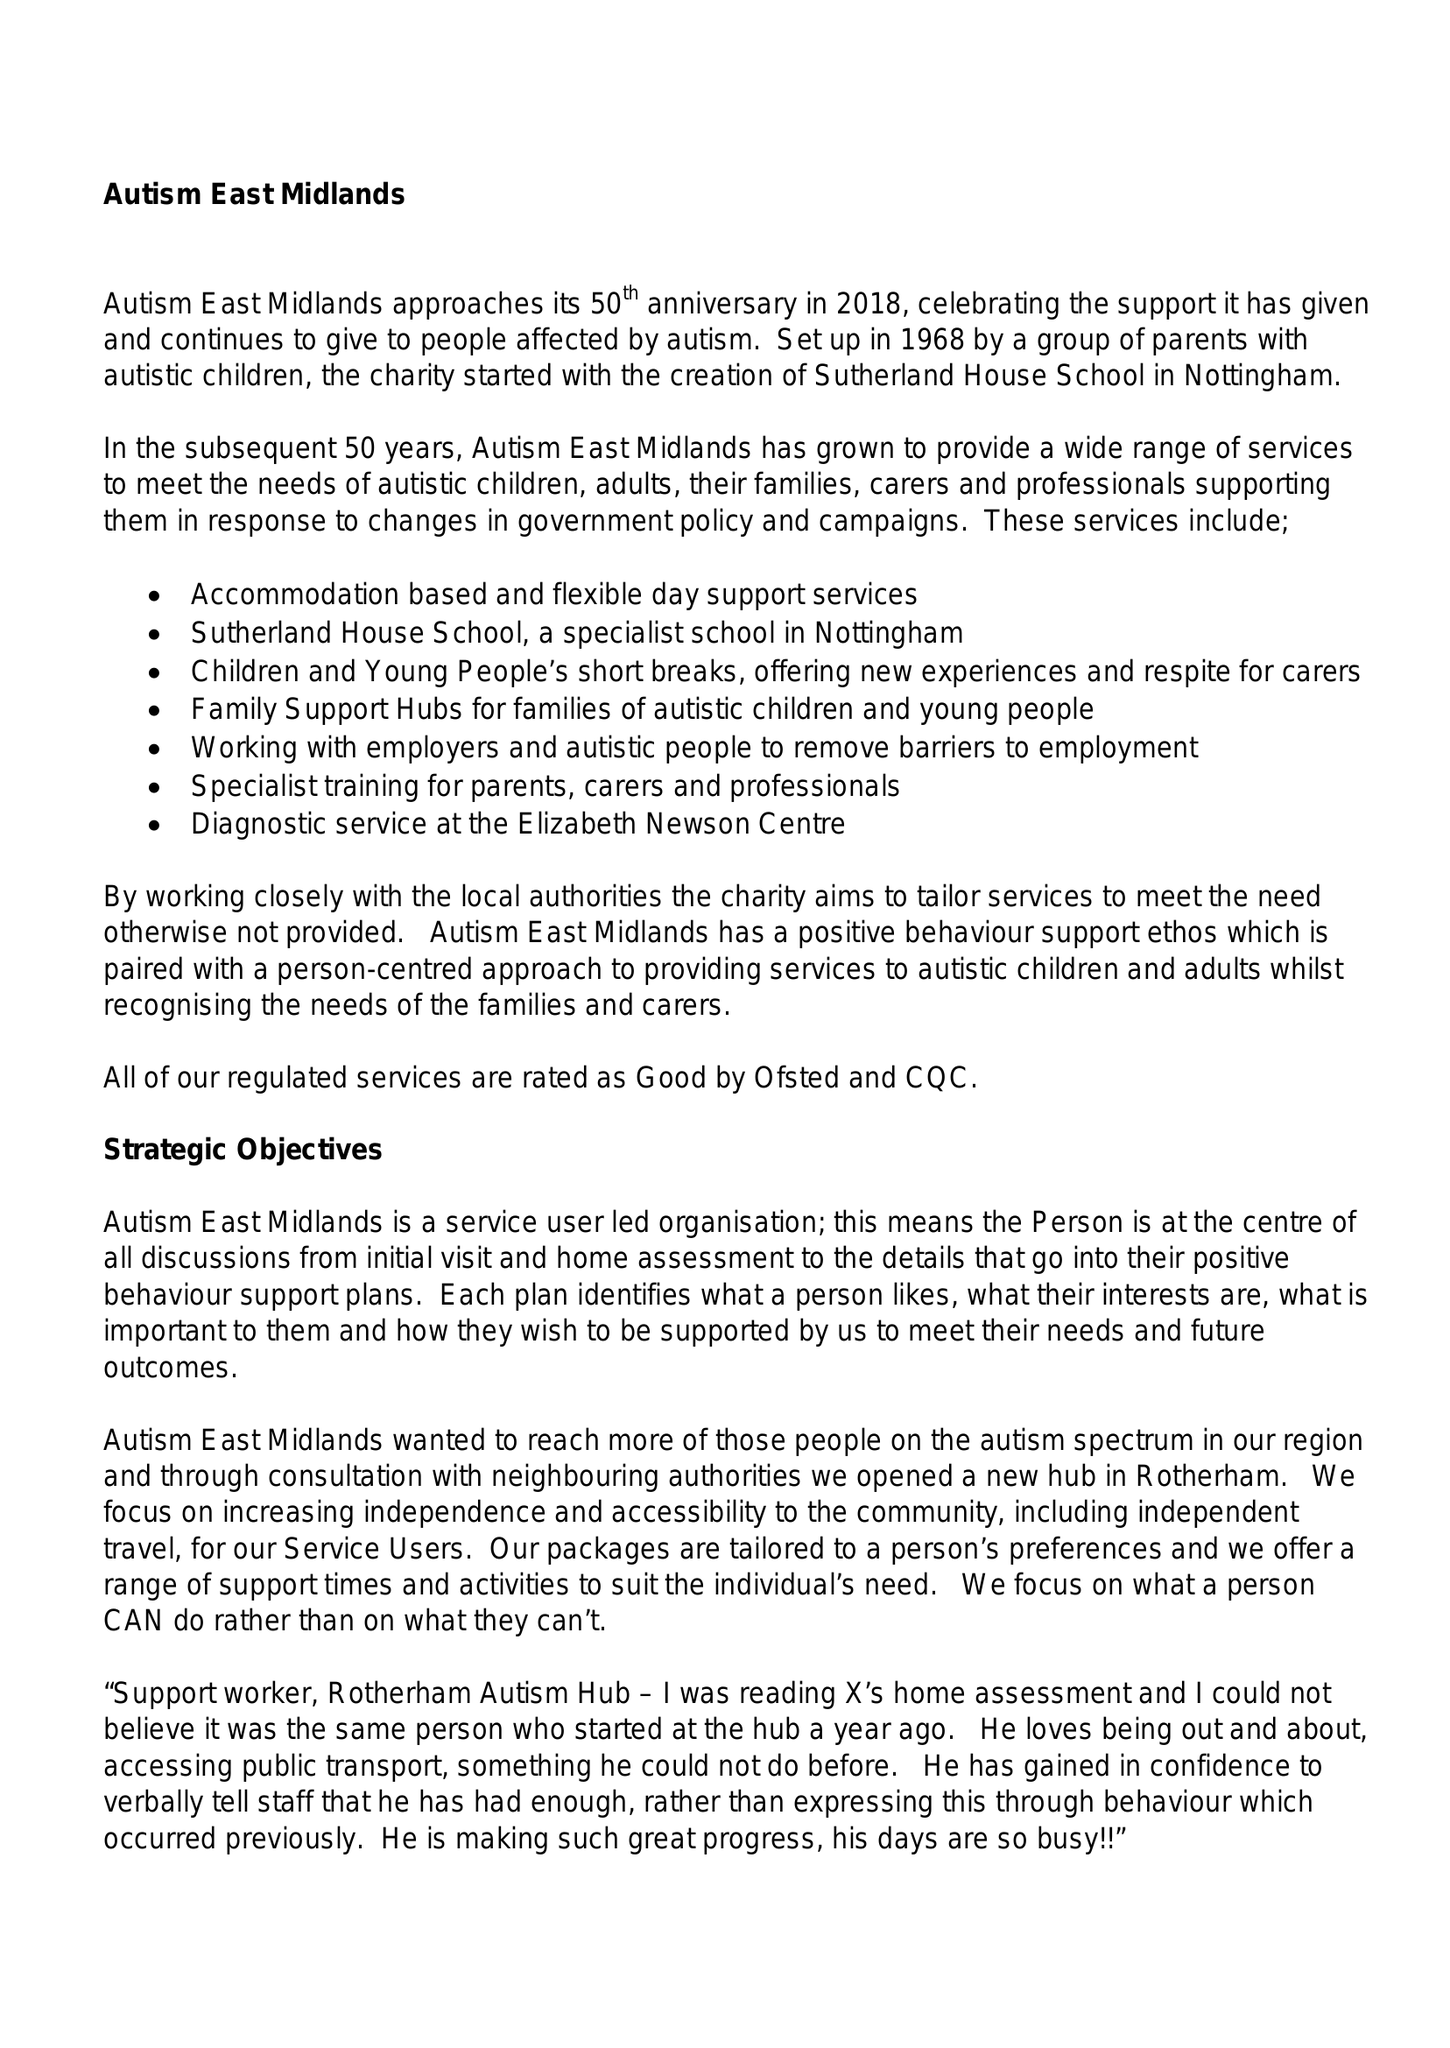What is the value for the income_annually_in_british_pounds?
Answer the question using a single word or phrase. 11474193.00 